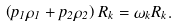Convert formula to latex. <formula><loc_0><loc_0><loc_500><loc_500>\left ( p _ { 1 } \rho _ { 1 } + p _ { 2 } \rho _ { 2 } \right ) R _ { k } = \omega _ { k } R _ { k } .</formula> 